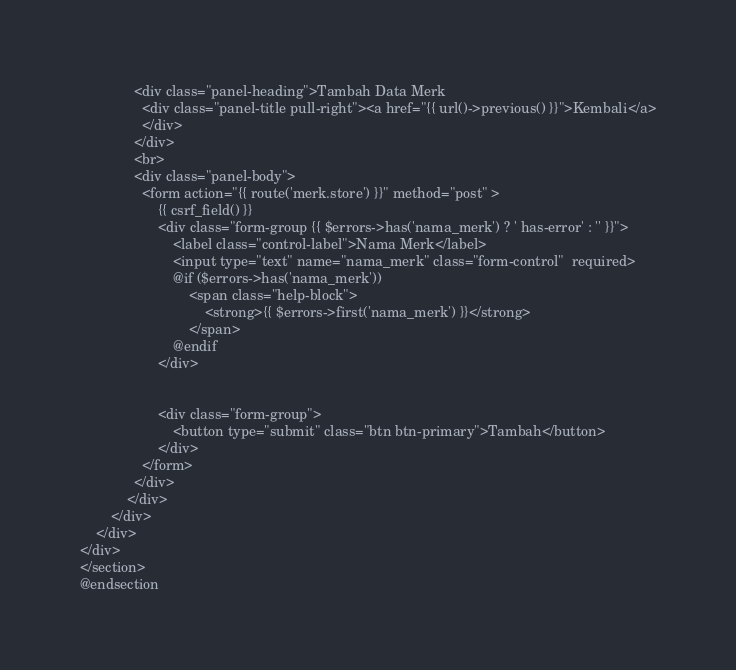Convert code to text. <code><loc_0><loc_0><loc_500><loc_500><_PHP_>			  <div class="panel-heading">Tambah Data Merk 
			  	<div class="panel-title pull-right"><a href="{{ url()->previous() }}">Kembali</a>
			  	</div>
			  </div>
			  <br>
			  <div class="panel-body">
			  	<form action="{{ route('merk.store') }}" method="post" >
			  		{{ csrf_field() }}
			  		<div class="form-group {{ $errors->has('nama_merk') ? ' has-error' : '' }}">
			  			<label class="control-label">Nama Merk</label>	
			  			<input type="text" name="nama_merk" class="form-control"  required>
			  			@if ($errors->has('nama_merk'))
                            <span class="help-block">
                                <strong>{{ $errors->first('nama_merk') }}</strong>
                            </span>
                        @endif
			  		</div>

			  		
			  		<div class="form-group">
			  			<button type="submit" class="btn btn-primary">Tambah</button>
			  		</div>
			  	</form>
			  </div>
			</div>	
		</div>
	</div>
</div>
</section>
@endsection</code> 